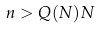Convert formula to latex. <formula><loc_0><loc_0><loc_500><loc_500>n > Q ( N ) N</formula> 